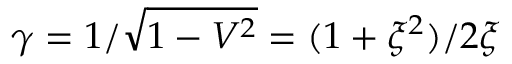Convert formula to latex. <formula><loc_0><loc_0><loc_500><loc_500>\gamma = 1 / \sqrt { 1 - V ^ { 2 } } = ( 1 + \xi ^ { 2 } ) / 2 \xi</formula> 